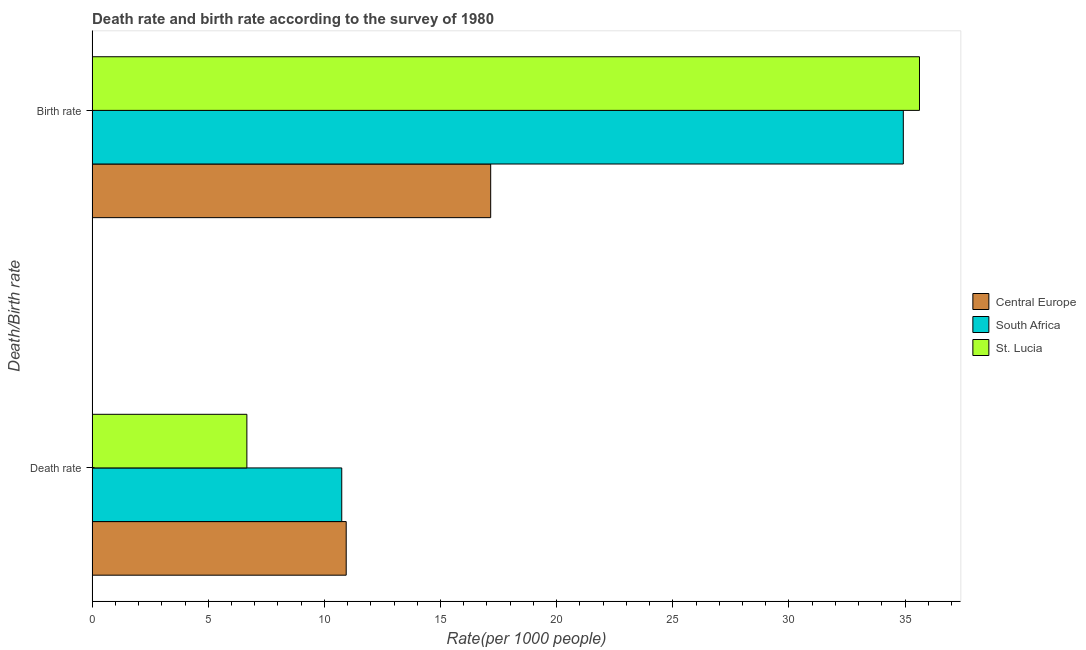How many bars are there on the 1st tick from the top?
Provide a succinct answer. 3. How many bars are there on the 1st tick from the bottom?
Keep it short and to the point. 3. What is the label of the 1st group of bars from the top?
Your answer should be compact. Birth rate. What is the birth rate in St. Lucia?
Ensure brevity in your answer.  35.62. Across all countries, what is the maximum death rate?
Your answer should be compact. 10.94. Across all countries, what is the minimum death rate?
Your answer should be very brief. 6.66. In which country was the birth rate maximum?
Your answer should be compact. St. Lucia. In which country was the birth rate minimum?
Ensure brevity in your answer.  Central Europe. What is the total birth rate in the graph?
Your answer should be very brief. 87.7. What is the difference between the birth rate in St. Lucia and that in South Africa?
Your answer should be very brief. 0.7. What is the difference between the birth rate in Central Europe and the death rate in St. Lucia?
Offer a very short reply. 10.5. What is the average death rate per country?
Make the answer very short. 9.45. What is the difference between the birth rate and death rate in St. Lucia?
Offer a very short reply. 28.96. What is the ratio of the birth rate in St. Lucia to that in South Africa?
Provide a succinct answer. 1.02. In how many countries, is the death rate greater than the average death rate taken over all countries?
Make the answer very short. 2. What does the 1st bar from the top in Birth rate represents?
Your response must be concise. St. Lucia. What does the 3rd bar from the bottom in Birth rate represents?
Provide a short and direct response. St. Lucia. How many bars are there?
Keep it short and to the point. 6. Are all the bars in the graph horizontal?
Your response must be concise. Yes. How many countries are there in the graph?
Your answer should be compact. 3. Does the graph contain any zero values?
Offer a very short reply. No. Does the graph contain grids?
Offer a very short reply. No. Where does the legend appear in the graph?
Your answer should be compact. Center right. How are the legend labels stacked?
Your response must be concise. Vertical. What is the title of the graph?
Offer a terse response. Death rate and birth rate according to the survey of 1980. Does "Sudan" appear as one of the legend labels in the graph?
Keep it short and to the point. No. What is the label or title of the X-axis?
Provide a short and direct response. Rate(per 1000 people). What is the label or title of the Y-axis?
Offer a very short reply. Death/Birth rate. What is the Rate(per 1000 people) in Central Europe in Death rate?
Provide a short and direct response. 10.94. What is the Rate(per 1000 people) of South Africa in Death rate?
Offer a terse response. 10.75. What is the Rate(per 1000 people) of St. Lucia in Death rate?
Provide a short and direct response. 6.66. What is the Rate(per 1000 people) in Central Europe in Birth rate?
Keep it short and to the point. 17.16. What is the Rate(per 1000 people) in South Africa in Birth rate?
Your answer should be compact. 34.92. What is the Rate(per 1000 people) of St. Lucia in Birth rate?
Your answer should be very brief. 35.62. Across all Death/Birth rate, what is the maximum Rate(per 1000 people) of Central Europe?
Your answer should be very brief. 17.16. Across all Death/Birth rate, what is the maximum Rate(per 1000 people) of South Africa?
Keep it short and to the point. 34.92. Across all Death/Birth rate, what is the maximum Rate(per 1000 people) in St. Lucia?
Ensure brevity in your answer.  35.62. Across all Death/Birth rate, what is the minimum Rate(per 1000 people) of Central Europe?
Your response must be concise. 10.94. Across all Death/Birth rate, what is the minimum Rate(per 1000 people) in South Africa?
Offer a terse response. 10.75. Across all Death/Birth rate, what is the minimum Rate(per 1000 people) in St. Lucia?
Your answer should be very brief. 6.66. What is the total Rate(per 1000 people) in Central Europe in the graph?
Provide a short and direct response. 28.1. What is the total Rate(per 1000 people) of South Africa in the graph?
Your answer should be compact. 45.67. What is the total Rate(per 1000 people) of St. Lucia in the graph?
Offer a very short reply. 42.28. What is the difference between the Rate(per 1000 people) of Central Europe in Death rate and that in Birth rate?
Your response must be concise. -6.22. What is the difference between the Rate(per 1000 people) of South Africa in Death rate and that in Birth rate?
Offer a very short reply. -24.18. What is the difference between the Rate(per 1000 people) in St. Lucia in Death rate and that in Birth rate?
Ensure brevity in your answer.  -28.96. What is the difference between the Rate(per 1000 people) of Central Europe in Death rate and the Rate(per 1000 people) of South Africa in Birth rate?
Provide a short and direct response. -23.98. What is the difference between the Rate(per 1000 people) in Central Europe in Death rate and the Rate(per 1000 people) in St. Lucia in Birth rate?
Give a very brief answer. -24.68. What is the difference between the Rate(per 1000 people) of South Africa in Death rate and the Rate(per 1000 people) of St. Lucia in Birth rate?
Your answer should be compact. -24.87. What is the average Rate(per 1000 people) of Central Europe per Death/Birth rate?
Ensure brevity in your answer.  14.05. What is the average Rate(per 1000 people) in South Africa per Death/Birth rate?
Make the answer very short. 22.84. What is the average Rate(per 1000 people) of St. Lucia per Death/Birth rate?
Provide a succinct answer. 21.14. What is the difference between the Rate(per 1000 people) of Central Europe and Rate(per 1000 people) of South Africa in Death rate?
Give a very brief answer. 0.19. What is the difference between the Rate(per 1000 people) in Central Europe and Rate(per 1000 people) in St. Lucia in Death rate?
Make the answer very short. 4.28. What is the difference between the Rate(per 1000 people) of South Africa and Rate(per 1000 people) of St. Lucia in Death rate?
Offer a very short reply. 4.08. What is the difference between the Rate(per 1000 people) in Central Europe and Rate(per 1000 people) in South Africa in Birth rate?
Your answer should be very brief. -17.76. What is the difference between the Rate(per 1000 people) in Central Europe and Rate(per 1000 people) in St. Lucia in Birth rate?
Give a very brief answer. -18.46. What is the difference between the Rate(per 1000 people) in South Africa and Rate(per 1000 people) in St. Lucia in Birth rate?
Your answer should be compact. -0.7. What is the ratio of the Rate(per 1000 people) of Central Europe in Death rate to that in Birth rate?
Your response must be concise. 0.64. What is the ratio of the Rate(per 1000 people) in South Africa in Death rate to that in Birth rate?
Provide a short and direct response. 0.31. What is the ratio of the Rate(per 1000 people) in St. Lucia in Death rate to that in Birth rate?
Make the answer very short. 0.19. What is the difference between the highest and the second highest Rate(per 1000 people) in Central Europe?
Provide a short and direct response. 6.22. What is the difference between the highest and the second highest Rate(per 1000 people) of South Africa?
Provide a short and direct response. 24.18. What is the difference between the highest and the second highest Rate(per 1000 people) of St. Lucia?
Ensure brevity in your answer.  28.96. What is the difference between the highest and the lowest Rate(per 1000 people) of Central Europe?
Your response must be concise. 6.22. What is the difference between the highest and the lowest Rate(per 1000 people) of South Africa?
Ensure brevity in your answer.  24.18. What is the difference between the highest and the lowest Rate(per 1000 people) of St. Lucia?
Offer a terse response. 28.96. 